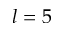Convert formula to latex. <formula><loc_0><loc_0><loc_500><loc_500>l = 5</formula> 